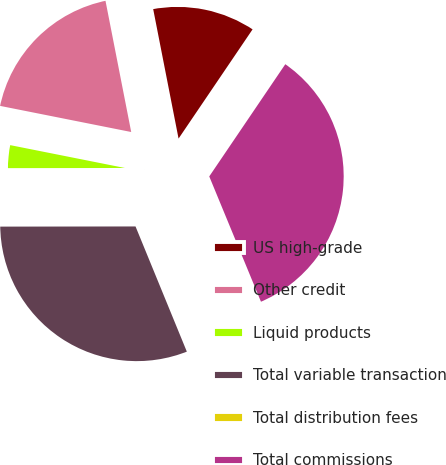<chart> <loc_0><loc_0><loc_500><loc_500><pie_chart><fcel>US high-grade<fcel>Other credit<fcel>Liquid products<fcel>Total variable transaction<fcel>Total distribution fees<fcel>Total commissions<nl><fcel>12.56%<fcel>18.79%<fcel>3.15%<fcel>31.17%<fcel>0.04%<fcel>34.29%<nl></chart> 